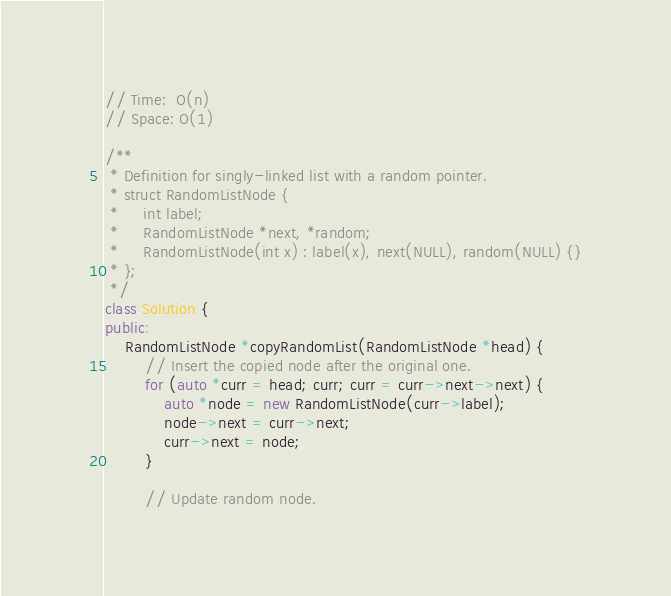Convert code to text. <code><loc_0><loc_0><loc_500><loc_500><_C++_>// Time:  O(n)
// Space: O(1)

/**
 * Definition for singly-linked list with a random pointer.
 * struct RandomListNode {
 *     int label;
 *     RandomListNode *next, *random;
 *     RandomListNode(int x) : label(x), next(NULL), random(NULL) {}
 * };
 */
class Solution {
public:
    RandomListNode *copyRandomList(RandomListNode *head) {
        // Insert the copied node after the original one.
        for (auto *curr = head; curr; curr = curr->next->next) {
            auto *node = new RandomListNode(curr->label);
            node->next = curr->next;
            curr->next = node;
        }

        // Update random node.</code> 